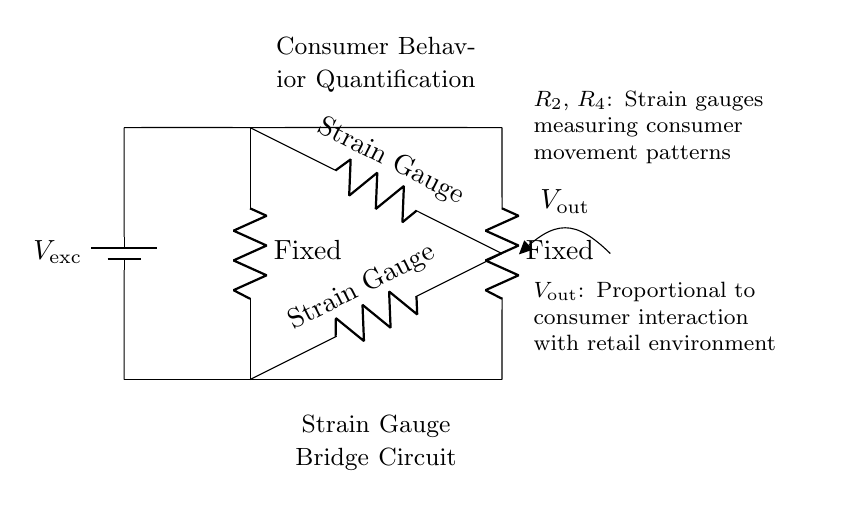What is the function of \( R_2 \)? \( R_2 \) is described as the "Strain Gauge", which indicates its role in measuring strain or deformation in response to consumer behavior in the retail environment.
Answer: Strain Gauge What type of circuit is shown? The circuit is a "Bridge" configuration, specifically a strain gauge bridge circuit used for measurement by balancing two sides. This is evident from the arrangement of resistors in a quadrilateral structure.
Answer: Bridge What does \( V_{\text{out}} \) represent? \( V_{\text{out}} \) is the output voltage which is "Proportional to consumer interaction with retail environment", indicating that it measures the effect of consumer behavior as represented by the change in voltage.
Answer: Proportional to consumer interaction How many strain gauges are present in this circuit? The circuit diagram shows two resistances described as strain gauges: \( R_2 \) and \( R_4 \). This counts the number of strain gauges directly indicated in the circuit.
Answer: Two What impact do the fixed resistors \( R_1 \) and \( R_3 \) have on the circuit? The fixed resistors \( R_1 \) and \( R_3 \) provide a stable reference for the strain gauges. They help balance the bridge circuit and affect the sensitivity and output characteristics.
Answer: Stable reference What is the purpose of the voltage source? The voltage source \( V_{\text{exc}} \) is necessary to provide the excitation voltage needed for the operation of the strain gauges, enabling them to sense changes in resistance due to strain.
Answer: Provides excitation voltage 